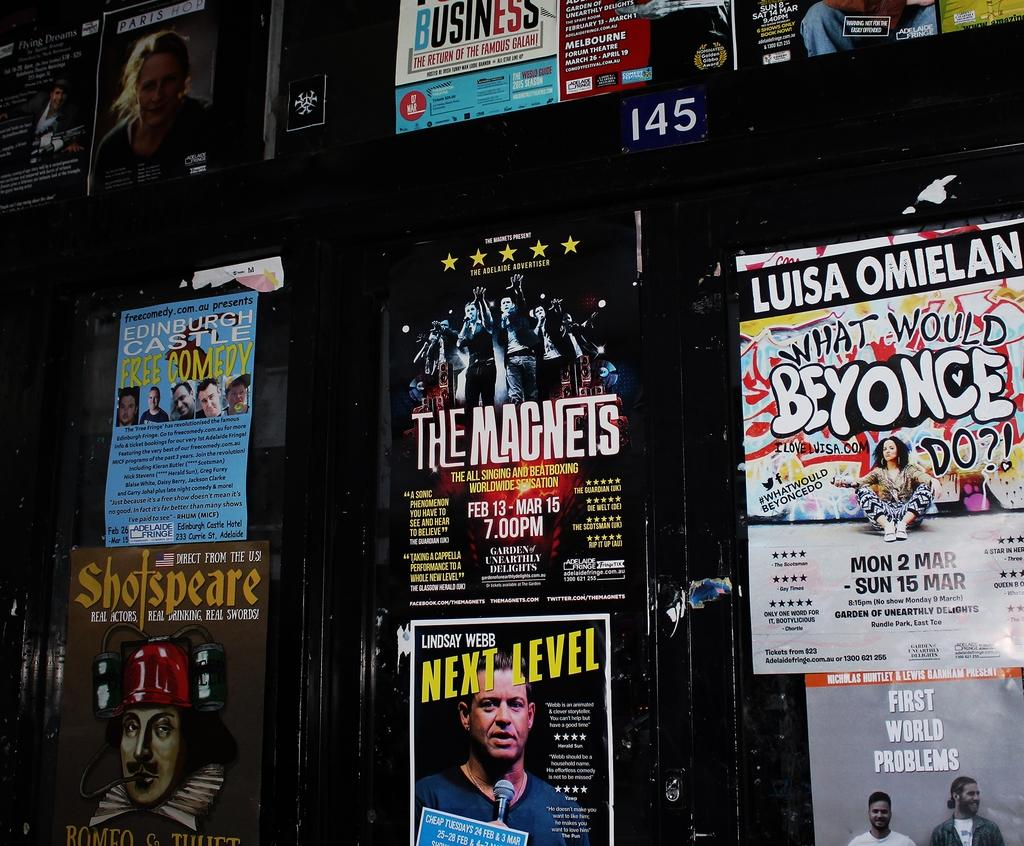What is attached to the wooden wall in the image? There are posters attached to a wooden wall in the image. What can be found on the shelf in the image? There are books on a shelf in the image. What type of silk material is draped over the seat in the image? There is no seat or silk material present in the image. 